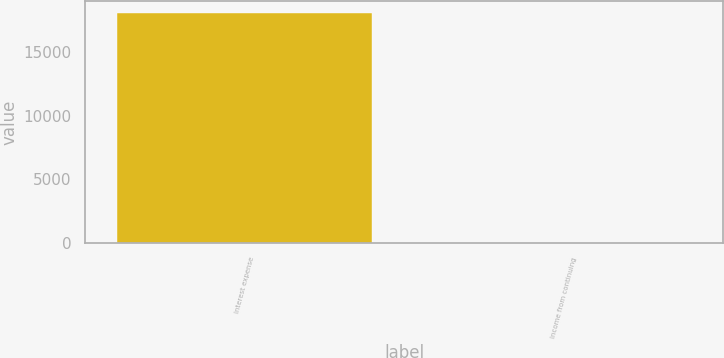Convert chart to OTSL. <chart><loc_0><loc_0><loc_500><loc_500><bar_chart><fcel>Interest expense<fcel>Income from continuing<nl><fcel>18090.4<fcel>35.12<nl></chart> 